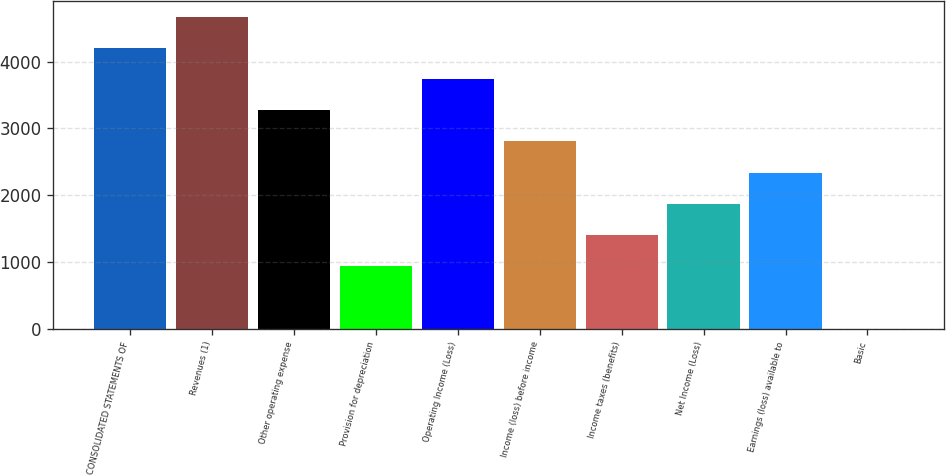Convert chart to OTSL. <chart><loc_0><loc_0><loc_500><loc_500><bar_chart><fcel>CONSOLIDATED STATEMENTS OF<fcel>Revenues (1)<fcel>Other operating expense<fcel>Provision for depreciation<fcel>Operating Income (Loss)<fcel>Income (loss) before income<fcel>Income taxes (benefits)<fcel>Net Income (Loss)<fcel>Earnings (loss) available to<fcel>Basic<nl><fcel>4206.7<fcel>4674<fcel>3272.16<fcel>935.81<fcel>3739.43<fcel>2804.89<fcel>1403.08<fcel>1870.35<fcel>2337.62<fcel>1.27<nl></chart> 